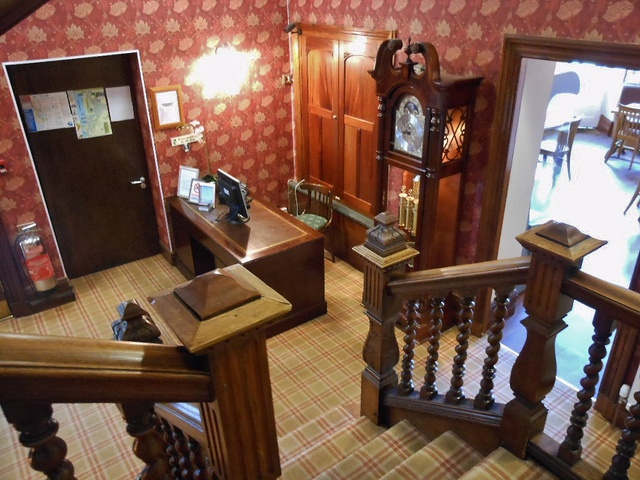Describe the objects in this image and their specific colors. I can see clock in black, darkgray, gray, and lightgray tones, chair in black, maroon, and gray tones, chair in black, white, gray, and darkgray tones, clock in black, white, tan, and brown tones, and tv in black, gray, and white tones in this image. 